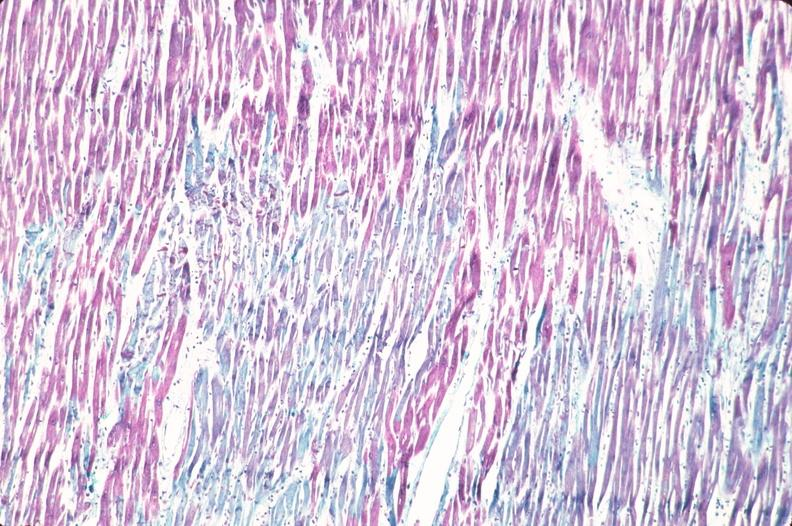s muscle atrophy present?
Answer the question using a single word or phrase. No 